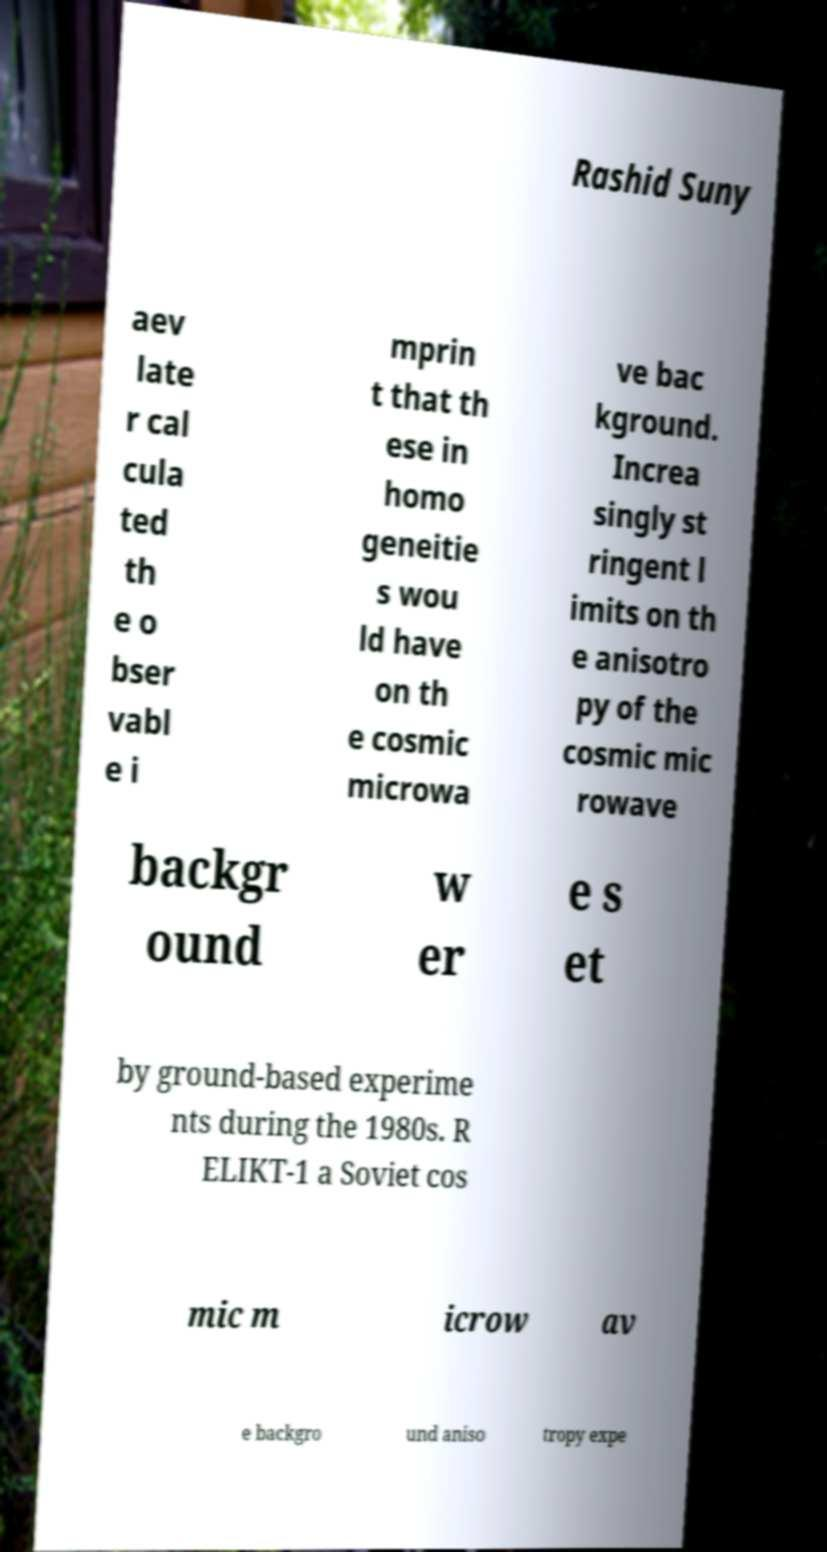There's text embedded in this image that I need extracted. Can you transcribe it verbatim? Rashid Suny aev late r cal cula ted th e o bser vabl e i mprin t that th ese in homo geneitie s wou ld have on th e cosmic microwa ve bac kground. Increa singly st ringent l imits on th e anisotro py of the cosmic mic rowave backgr ound w er e s et by ground-based experime nts during the 1980s. R ELIKT-1 a Soviet cos mic m icrow av e backgro und aniso tropy expe 